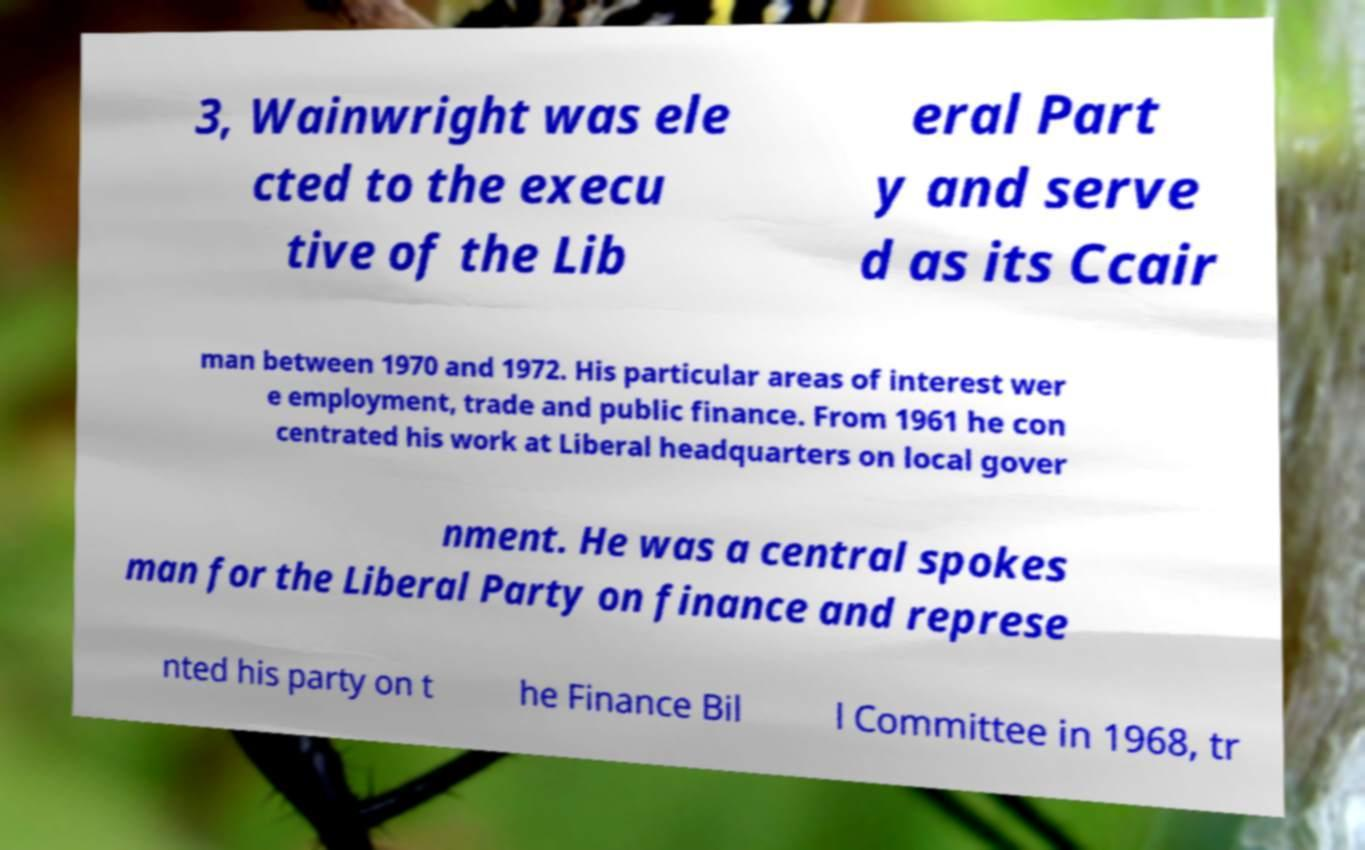Can you read and provide the text displayed in the image?This photo seems to have some interesting text. Can you extract and type it out for me? 3, Wainwright was ele cted to the execu tive of the Lib eral Part y and serve d as its Ccair man between 1970 and 1972. His particular areas of interest wer e employment, trade and public finance. From 1961 he con centrated his work at Liberal headquarters on local gover nment. He was a central spokes man for the Liberal Party on finance and represe nted his party on t he Finance Bil l Committee in 1968, tr 